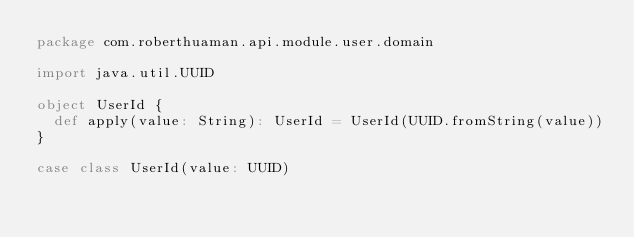Convert code to text. <code><loc_0><loc_0><loc_500><loc_500><_Scala_>package com.roberthuaman.api.module.user.domain

import java.util.UUID

object UserId {
  def apply(value: String): UserId = UserId(UUID.fromString(value))
}

case class UserId(value: UUID)
</code> 